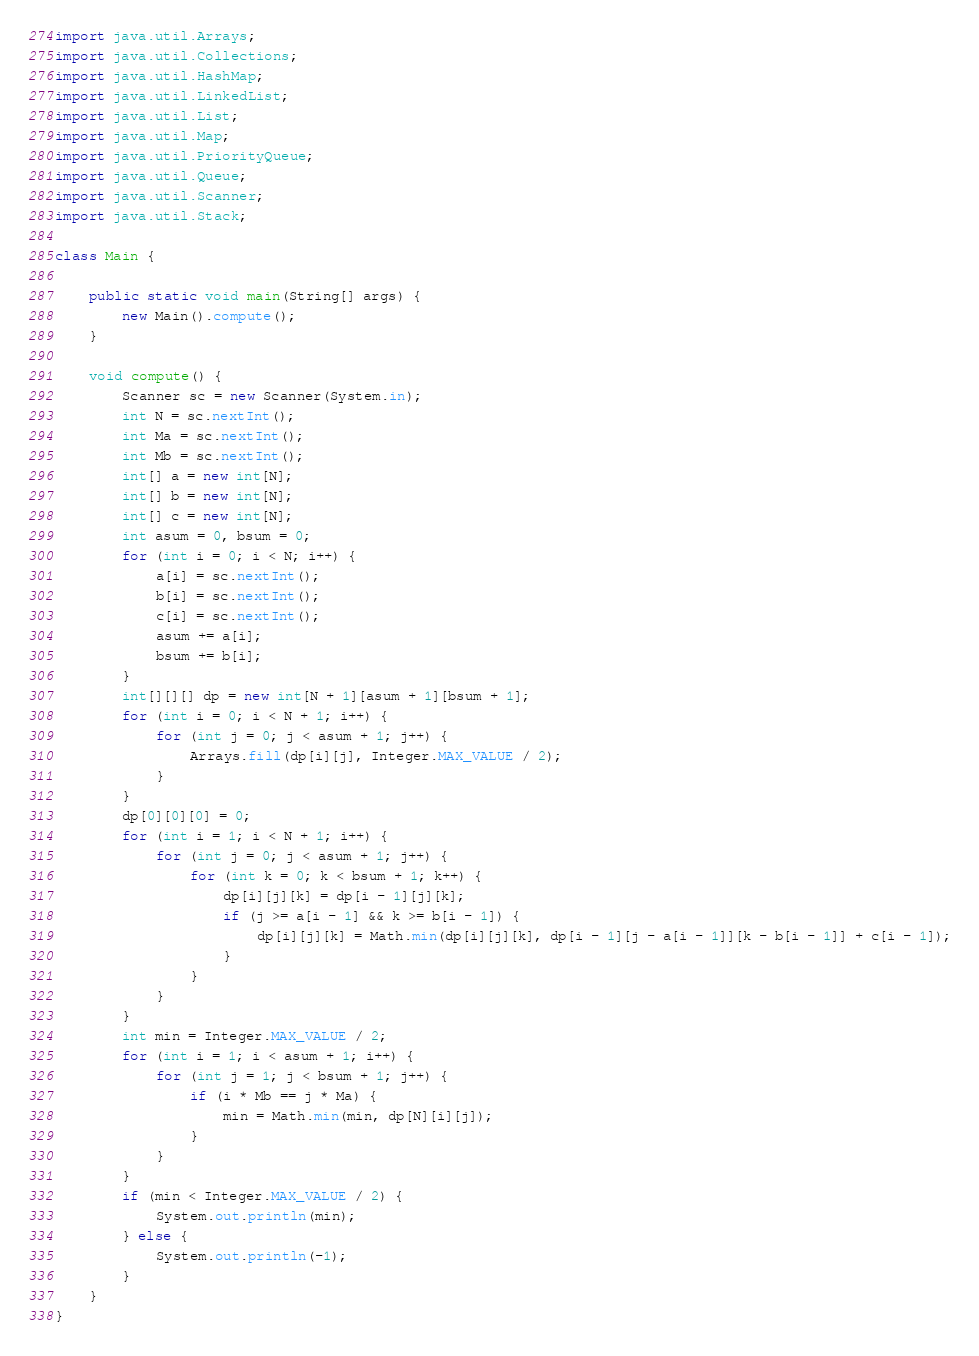<code> <loc_0><loc_0><loc_500><loc_500><_Java_>import java.util.Arrays;
import java.util.Collections;
import java.util.HashMap;
import java.util.LinkedList;
import java.util.List;
import java.util.Map;
import java.util.PriorityQueue;
import java.util.Queue;
import java.util.Scanner;
import java.util.Stack;

class Main {

    public static void main(String[] args) {
        new Main().compute();
    }

    void compute() {
        Scanner sc = new Scanner(System.in);
        int N = sc.nextInt();
        int Ma = sc.nextInt();
        int Mb = sc.nextInt();
        int[] a = new int[N];
        int[] b = new int[N];
        int[] c = new int[N];
        int asum = 0, bsum = 0;
        for (int i = 0; i < N; i++) {
            a[i] = sc.nextInt();
            b[i] = sc.nextInt();
            c[i] = sc.nextInt();
            asum += a[i];
            bsum += b[i];
        }
        int[][][] dp = new int[N + 1][asum + 1][bsum + 1];
        for (int i = 0; i < N + 1; i++) {
            for (int j = 0; j < asum + 1; j++) {
                Arrays.fill(dp[i][j], Integer.MAX_VALUE / 2);
            }
        }
        dp[0][0][0] = 0;
        for (int i = 1; i < N + 1; i++) {
            for (int j = 0; j < asum + 1; j++) {
                for (int k = 0; k < bsum + 1; k++) {
                    dp[i][j][k] = dp[i - 1][j][k];
                    if (j >= a[i - 1] && k >= b[i - 1]) {
                        dp[i][j][k] = Math.min(dp[i][j][k], dp[i - 1][j - a[i - 1]][k - b[i - 1]] + c[i - 1]);
                    }
                }
            }
        }
        int min = Integer.MAX_VALUE / 2;
        for (int i = 1; i < asum + 1; i++) {
            for (int j = 1; j < bsum + 1; j++) {
                if (i * Mb == j * Ma) {
                    min = Math.min(min, dp[N][i][j]);
                }
            }
        }
        if (min < Integer.MAX_VALUE / 2) {
            System.out.println(min);
        } else {
            System.out.println(-1);
        }
    }
}
</code> 